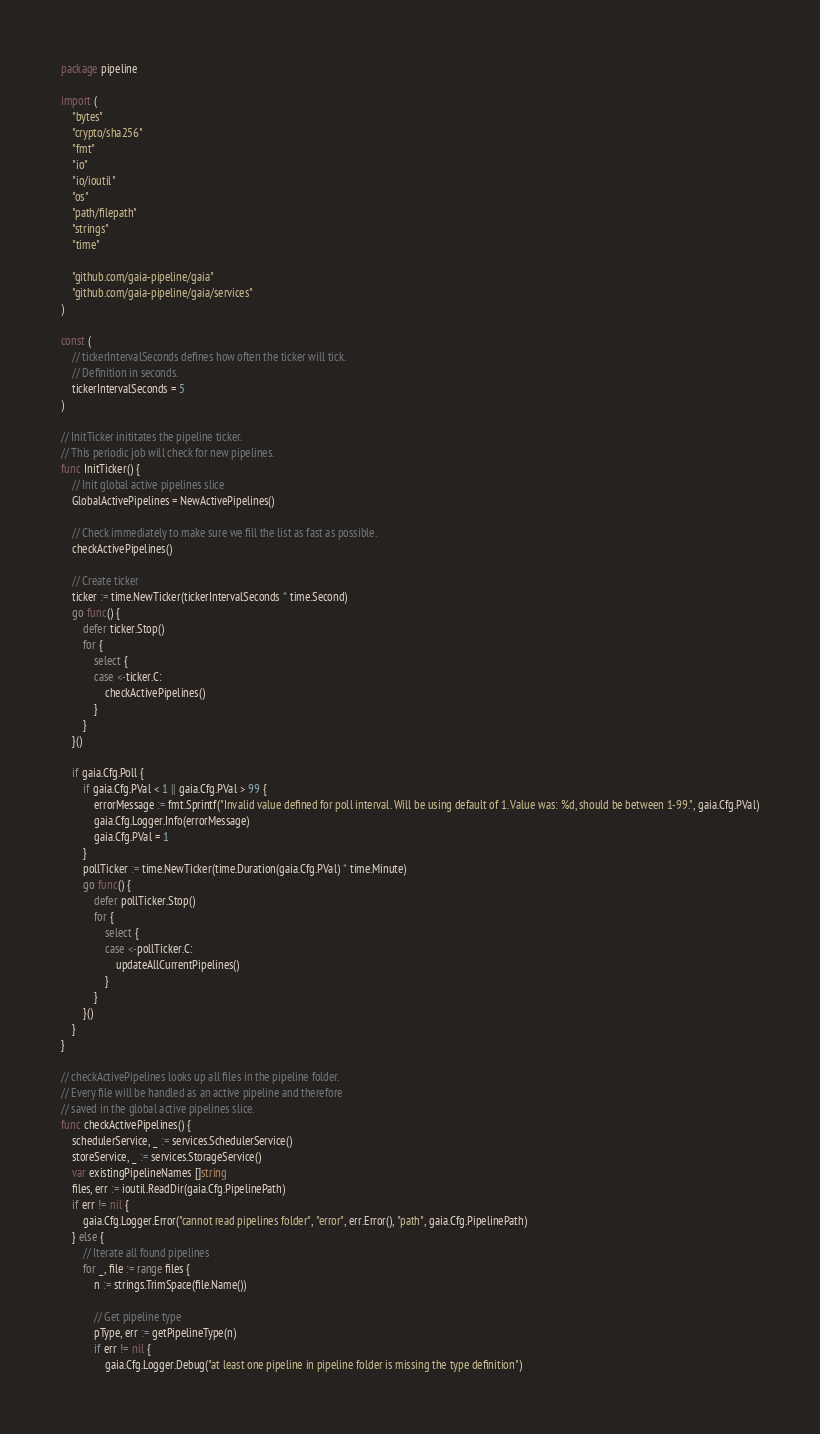Convert code to text. <code><loc_0><loc_0><loc_500><loc_500><_Go_>package pipeline

import (
	"bytes"
	"crypto/sha256"
	"fmt"
	"io"
	"io/ioutil"
	"os"
	"path/filepath"
	"strings"
	"time"

	"github.com/gaia-pipeline/gaia"
	"github.com/gaia-pipeline/gaia/services"
)

const (
	// tickerIntervalSeconds defines how often the ticker will tick.
	// Definition in seconds.
	tickerIntervalSeconds = 5
)

// InitTicker inititates the pipeline ticker.
// This periodic job will check for new pipelines.
func InitTicker() {
	// Init global active pipelines slice
	GlobalActivePipelines = NewActivePipelines()

	// Check immediately to make sure we fill the list as fast as possible.
	checkActivePipelines()

	// Create ticker
	ticker := time.NewTicker(tickerIntervalSeconds * time.Second)
	go func() {
		defer ticker.Stop()
		for {
			select {
			case <-ticker.C:
				checkActivePipelines()
			}
		}
	}()

	if gaia.Cfg.Poll {
		if gaia.Cfg.PVal < 1 || gaia.Cfg.PVal > 99 {
			errorMessage := fmt.Sprintf("Invalid value defined for poll interval. Will be using default of 1. Value was: %d, should be between 1-99.", gaia.Cfg.PVal)
			gaia.Cfg.Logger.Info(errorMessage)
			gaia.Cfg.PVal = 1
		}
		pollTicker := time.NewTicker(time.Duration(gaia.Cfg.PVal) * time.Minute)
		go func() {
			defer pollTicker.Stop()
			for {
				select {
				case <-pollTicker.C:
					updateAllCurrentPipelines()
				}
			}
		}()
	}
}

// checkActivePipelines looks up all files in the pipeline folder.
// Every file will be handled as an active pipeline and therefore
// saved in the global active pipelines slice.
func checkActivePipelines() {
	schedulerService, _ := services.SchedulerService()
	storeService, _ := services.StorageService()
	var existingPipelineNames []string
	files, err := ioutil.ReadDir(gaia.Cfg.PipelinePath)
	if err != nil {
		gaia.Cfg.Logger.Error("cannot read pipelines folder", "error", err.Error(), "path", gaia.Cfg.PipelinePath)
	} else {
		// Iterate all found pipelines
		for _, file := range files {
			n := strings.TrimSpace(file.Name())

			// Get pipeline type
			pType, err := getPipelineType(n)
			if err != nil {
				gaia.Cfg.Logger.Debug("at least one pipeline in pipeline folder is missing the type definition")</code> 